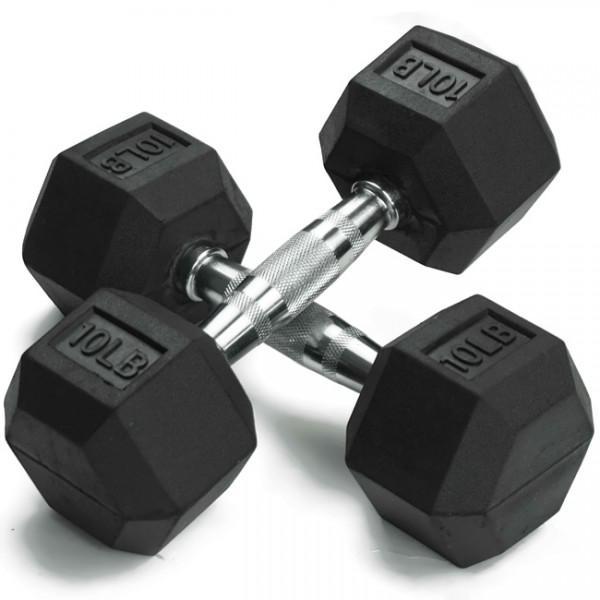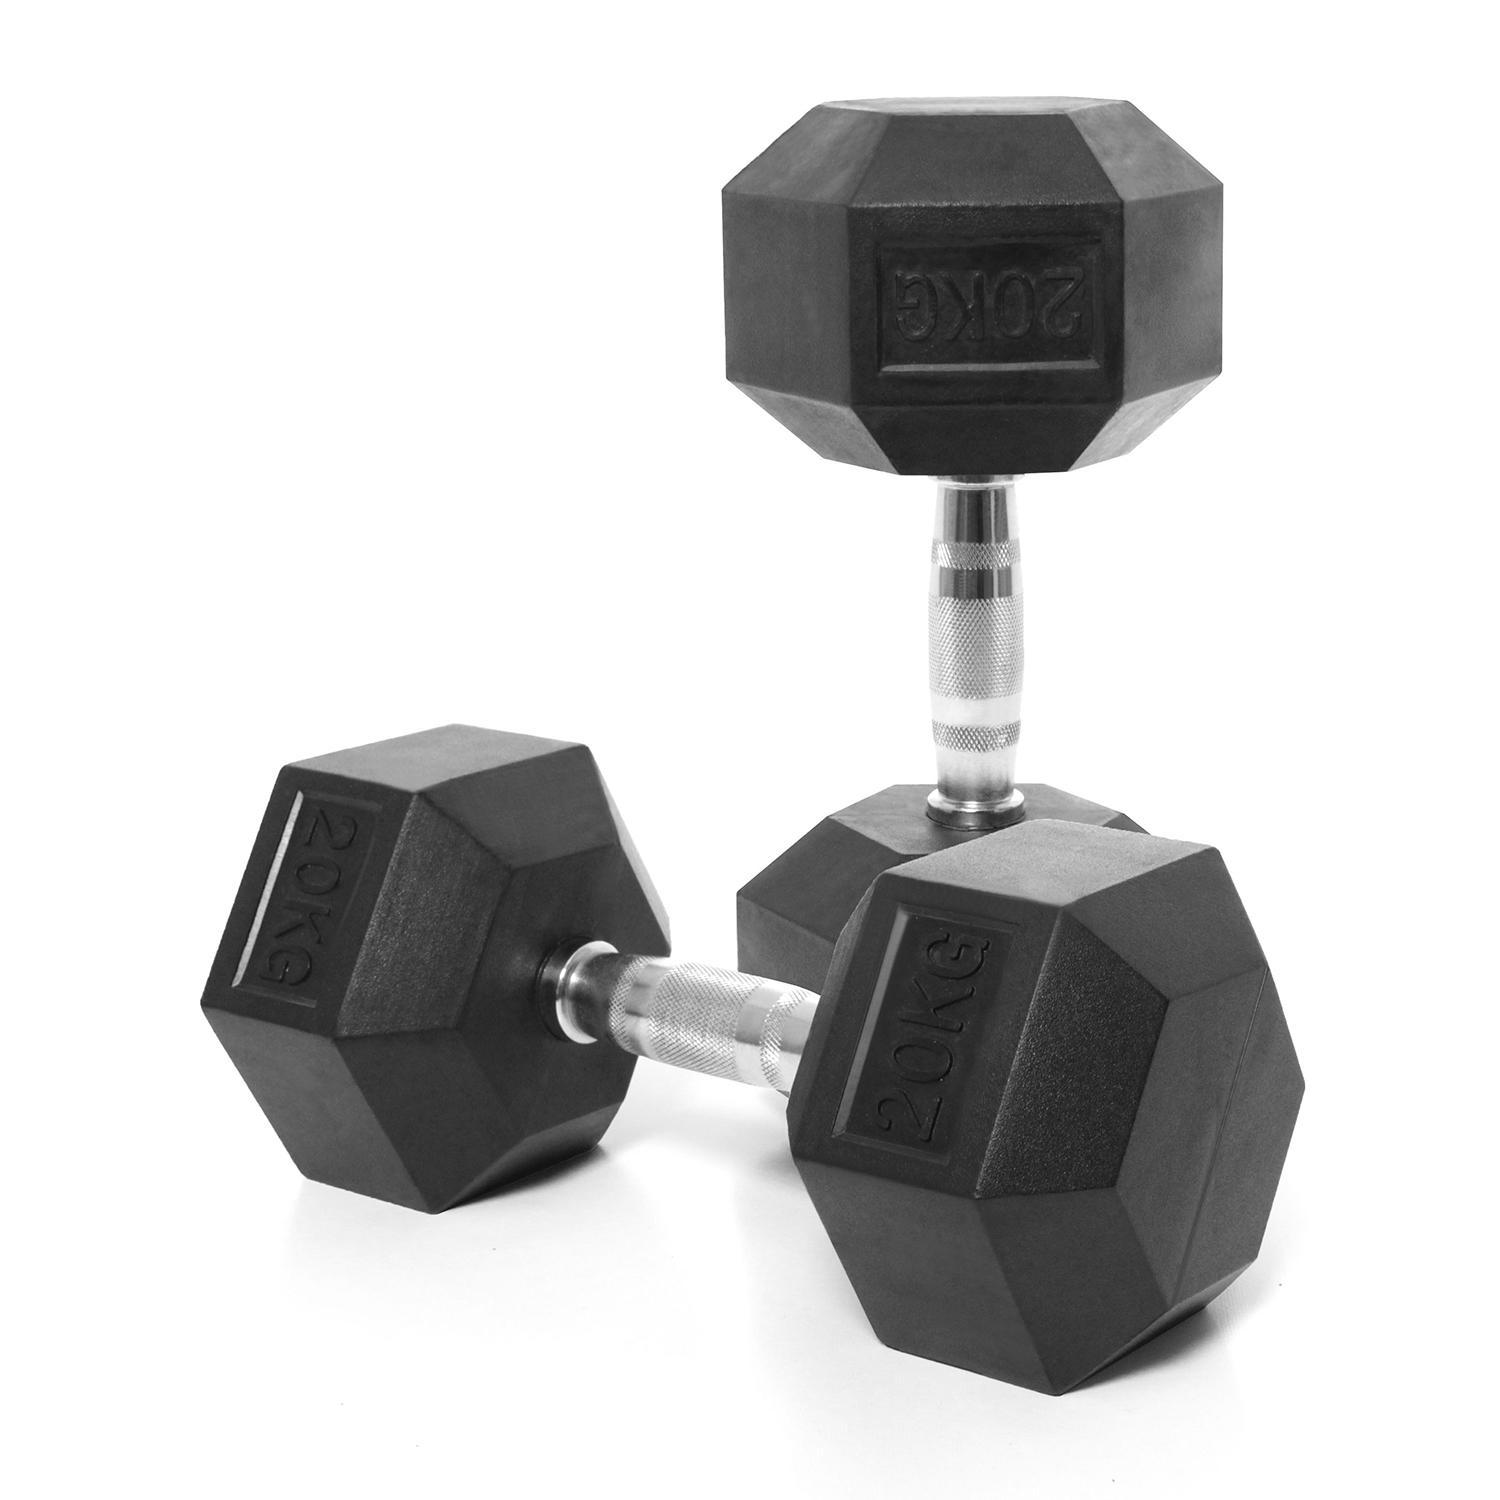The first image is the image on the left, the second image is the image on the right. Considering the images on both sides, is "The right image contains two dumbbells with black ends and a chrome middle bar." valid? Answer yes or no. Yes. The first image is the image on the left, the second image is the image on the right. Analyze the images presented: Is the assertion "Two hand weights in each image are a matched set, dark colored weights with six sides that are attached to a metal bar." valid? Answer yes or no. Yes. 